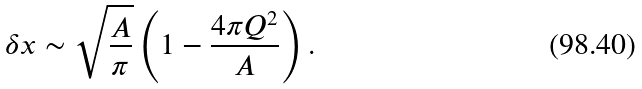<formula> <loc_0><loc_0><loc_500><loc_500>\delta x \sim \sqrt { \frac { A } { \pi } } \left ( 1 - \frac { 4 \pi Q ^ { 2 } } { A } \right ) .</formula> 